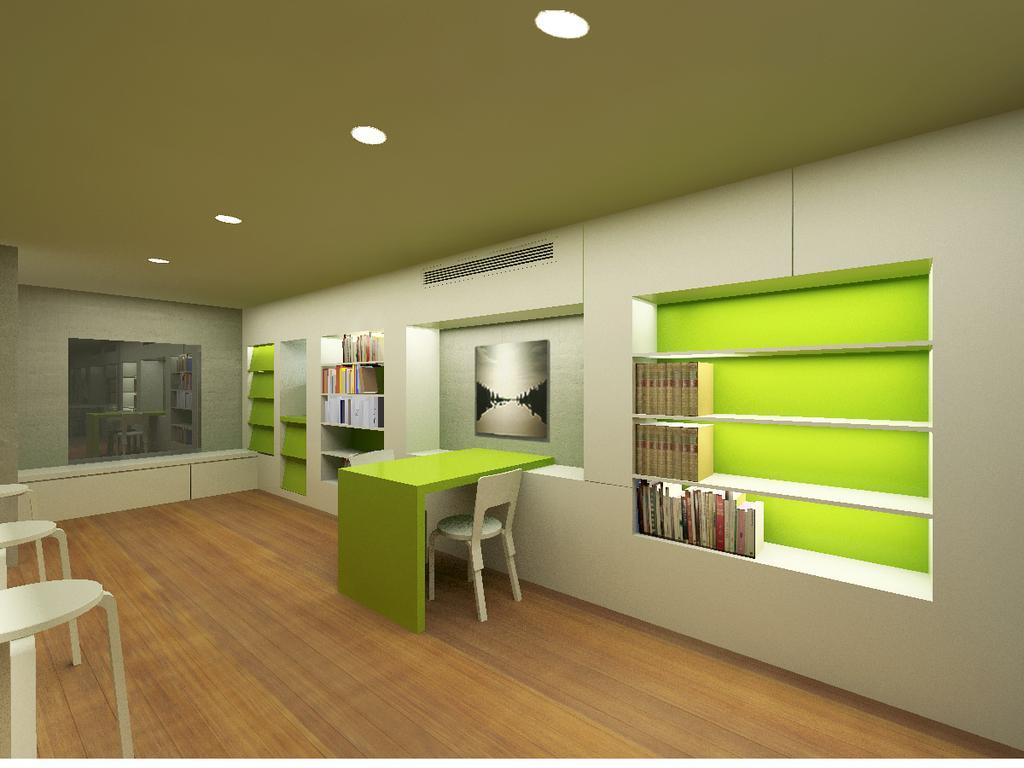In one or two sentences, can you explain what this image depicts? In this image, we can see a brown color floor, there is a table and there is a white color chair, there are some books kept in the shelves and at the left side there are some white color tables. 